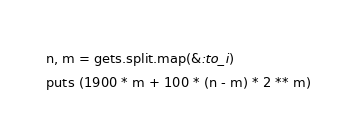Convert code to text. <code><loc_0><loc_0><loc_500><loc_500><_Ruby_>n, m = gets.split.map(&:to_i)
puts (1900 * m + 100 * (n - m) * 2 ** m)
</code> 